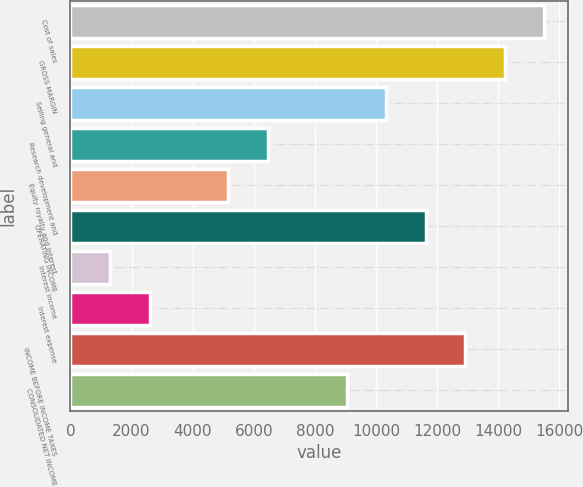<chart> <loc_0><loc_0><loc_500><loc_500><bar_chart><fcel>Cost of sales<fcel>GROSS MARGIN<fcel>Selling general and<fcel>Research development and<fcel>Equity royalty and interest<fcel>OPERATING INCOME<fcel>Interest income<fcel>Interest expense<fcel>INCOME BEFORE INCOME TAXES<fcel>CONSOLIDATED NET INCOME<nl><fcel>15500<fcel>14209<fcel>10336<fcel>6462.96<fcel>5171.95<fcel>11627<fcel>1298.92<fcel>2589.93<fcel>12918<fcel>9044.98<nl></chart> 